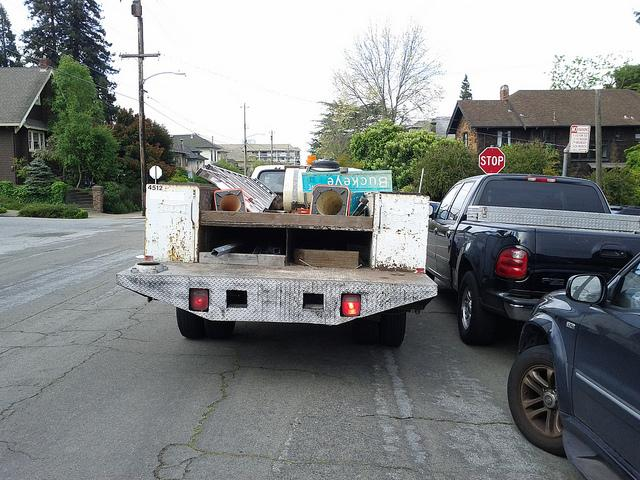Asphalts are used to construct what? Please explain your reasoning. roads. That's basically why it's made. 